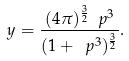<formula> <loc_0><loc_0><loc_500><loc_500>y = \frac { ( 4 \pi ) ^ { \frac { 3 } { 2 } } \ p ^ { 3 } } { ( 1 + \ p ^ { 3 } ) ^ { \frac { 3 } { 2 } } } .</formula> 